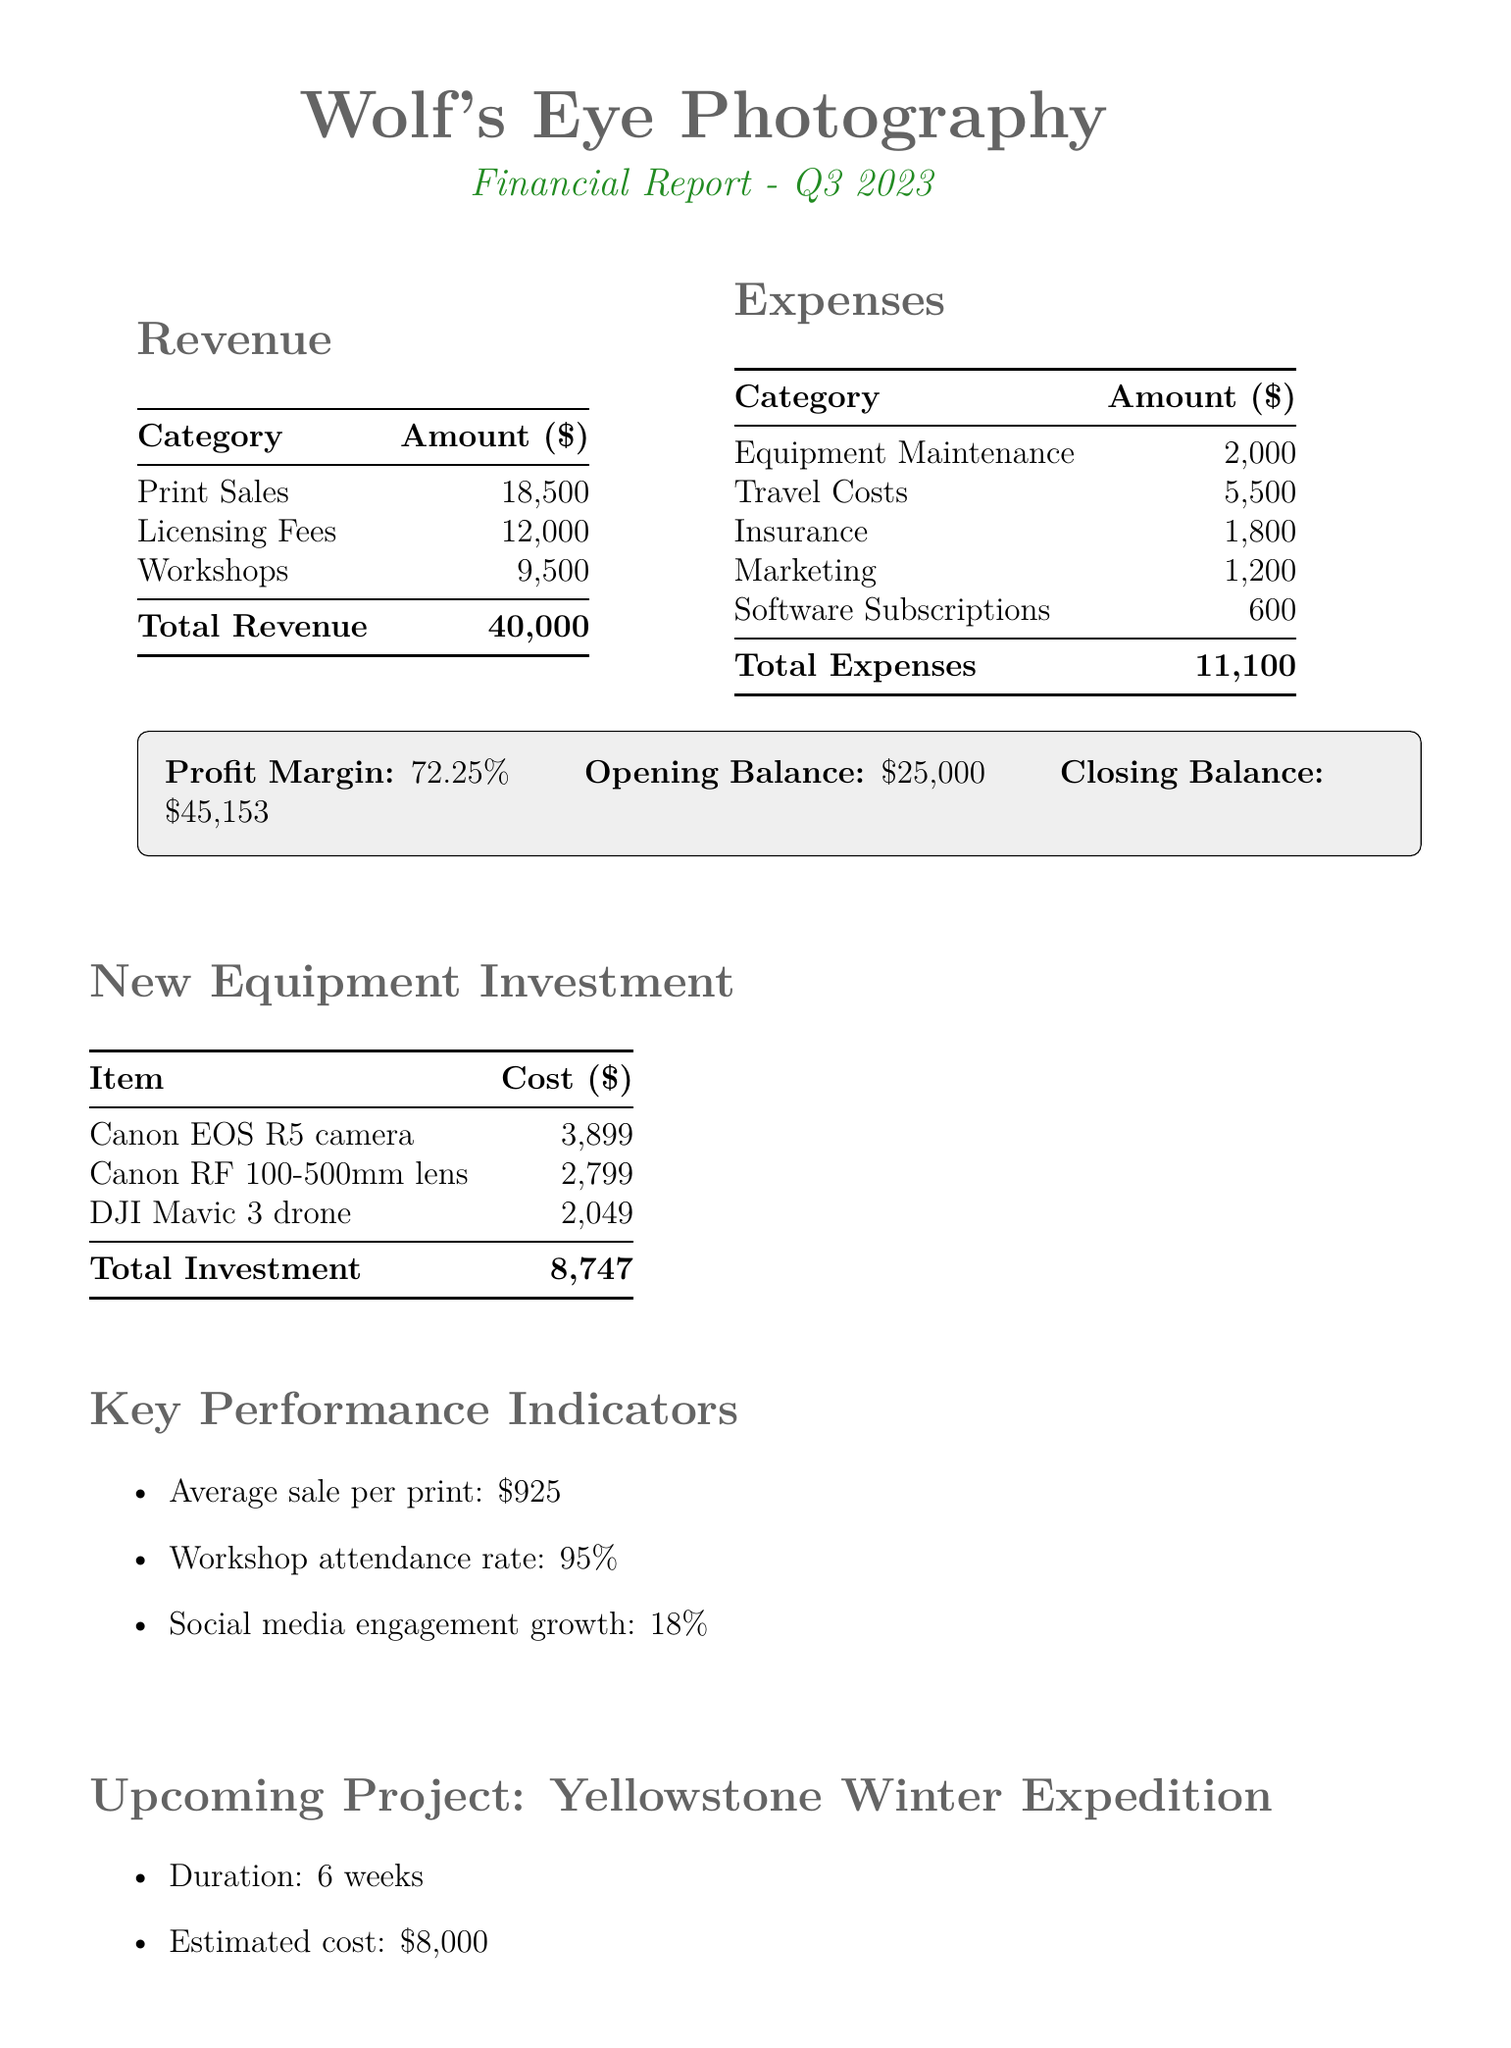What is the total revenue? The total revenue is the sum of all revenue sources in the document, which is 18500 + 12000 + 9500 = 40000.
Answer: 40000 What is the profit margin? The profit margin is stated directly in the document as a percentage of profit relative to total revenue.
Answer: 72.25% How much was spent on travel costs? The expenses category lists specific costs, and travel costs are noted as 5500.
Answer: 5500 What is the total investment in new equipment? The document provides a breakdown of equipment costs, which adds up to 8747.
Answer: 8747 What is the expected revenue from the upcoming project? The expected revenue for the Yellowstone Winter Expedition is indicated as 22000 in the future projects section.
Answer: 22000 What is the workshop attendance rate? The document states that the workshop attendance rate is 95%.
Answer: 95% How much did insurance cost? Insurance costs are detailed in the expenses section as 1800.
Answer: 1800 What is the estimated cost of the Yellowstone winter expedition? The document explicitly mentions the estimated cost of the upcoming project as 8000.
Answer: 8000 What camera was purchased as new equipment? The document lists specific cameras purchased, including the Canon EOS R5 camera.
Answer: Canon EOS R5 camera 